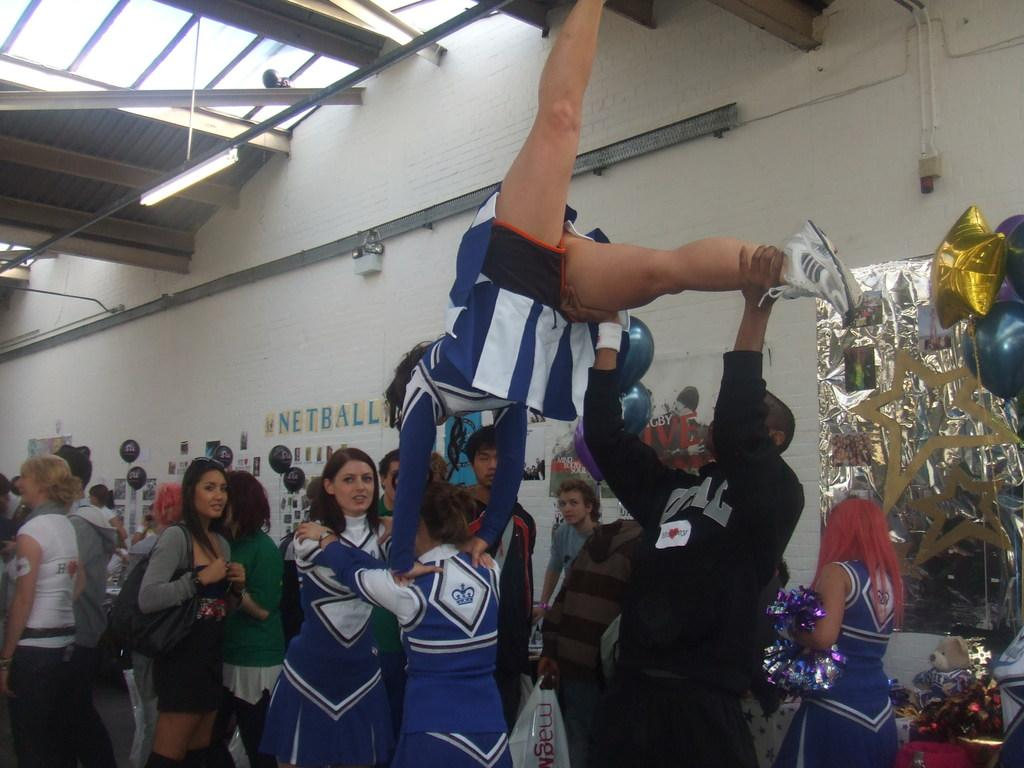Provide a one-sentence caption for the provided image. A cheerleading squad stand in a stadium with the word netball stuck on the wall. 